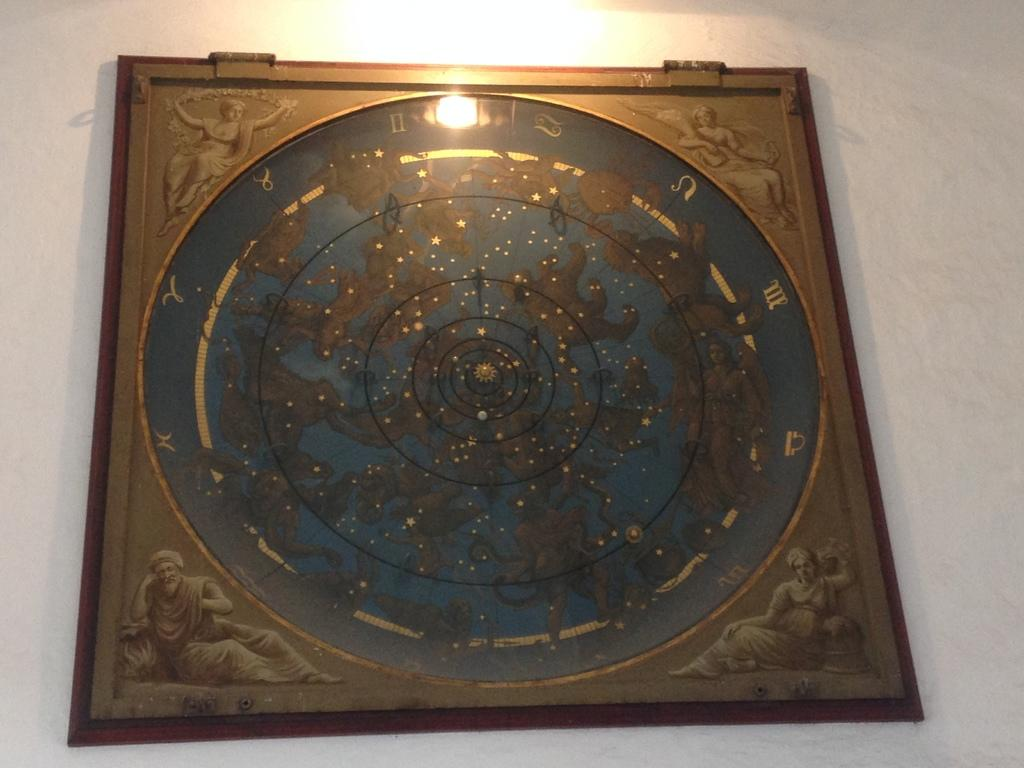What is hanging on the wall in the image? There is a zodiac sign frame on the wall in the image. What can be seen at the top of the image? There is a light focus at the top of the image. What type of metal is used to create the rock in the image? There is no metal or rock present in the image; it only features a zodiac sign frame and a light focus. 